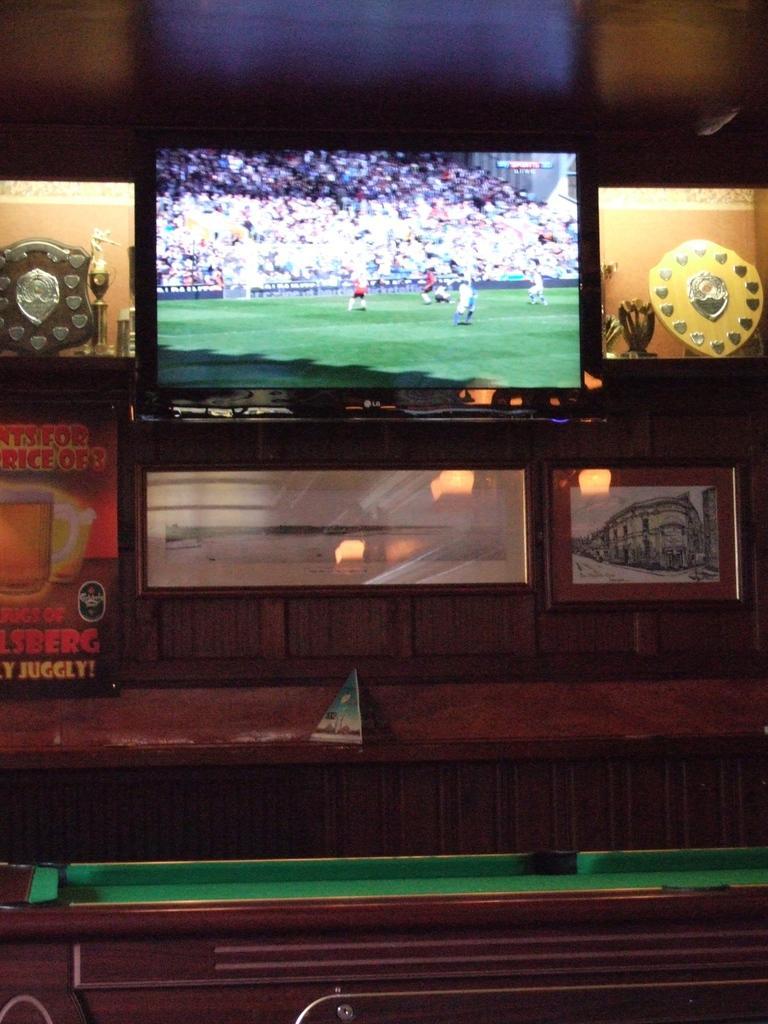How would you summarize this image in a sentence or two? Here there is a television , here there are awards, here there is glass with drink in it, here there is snooker board. 